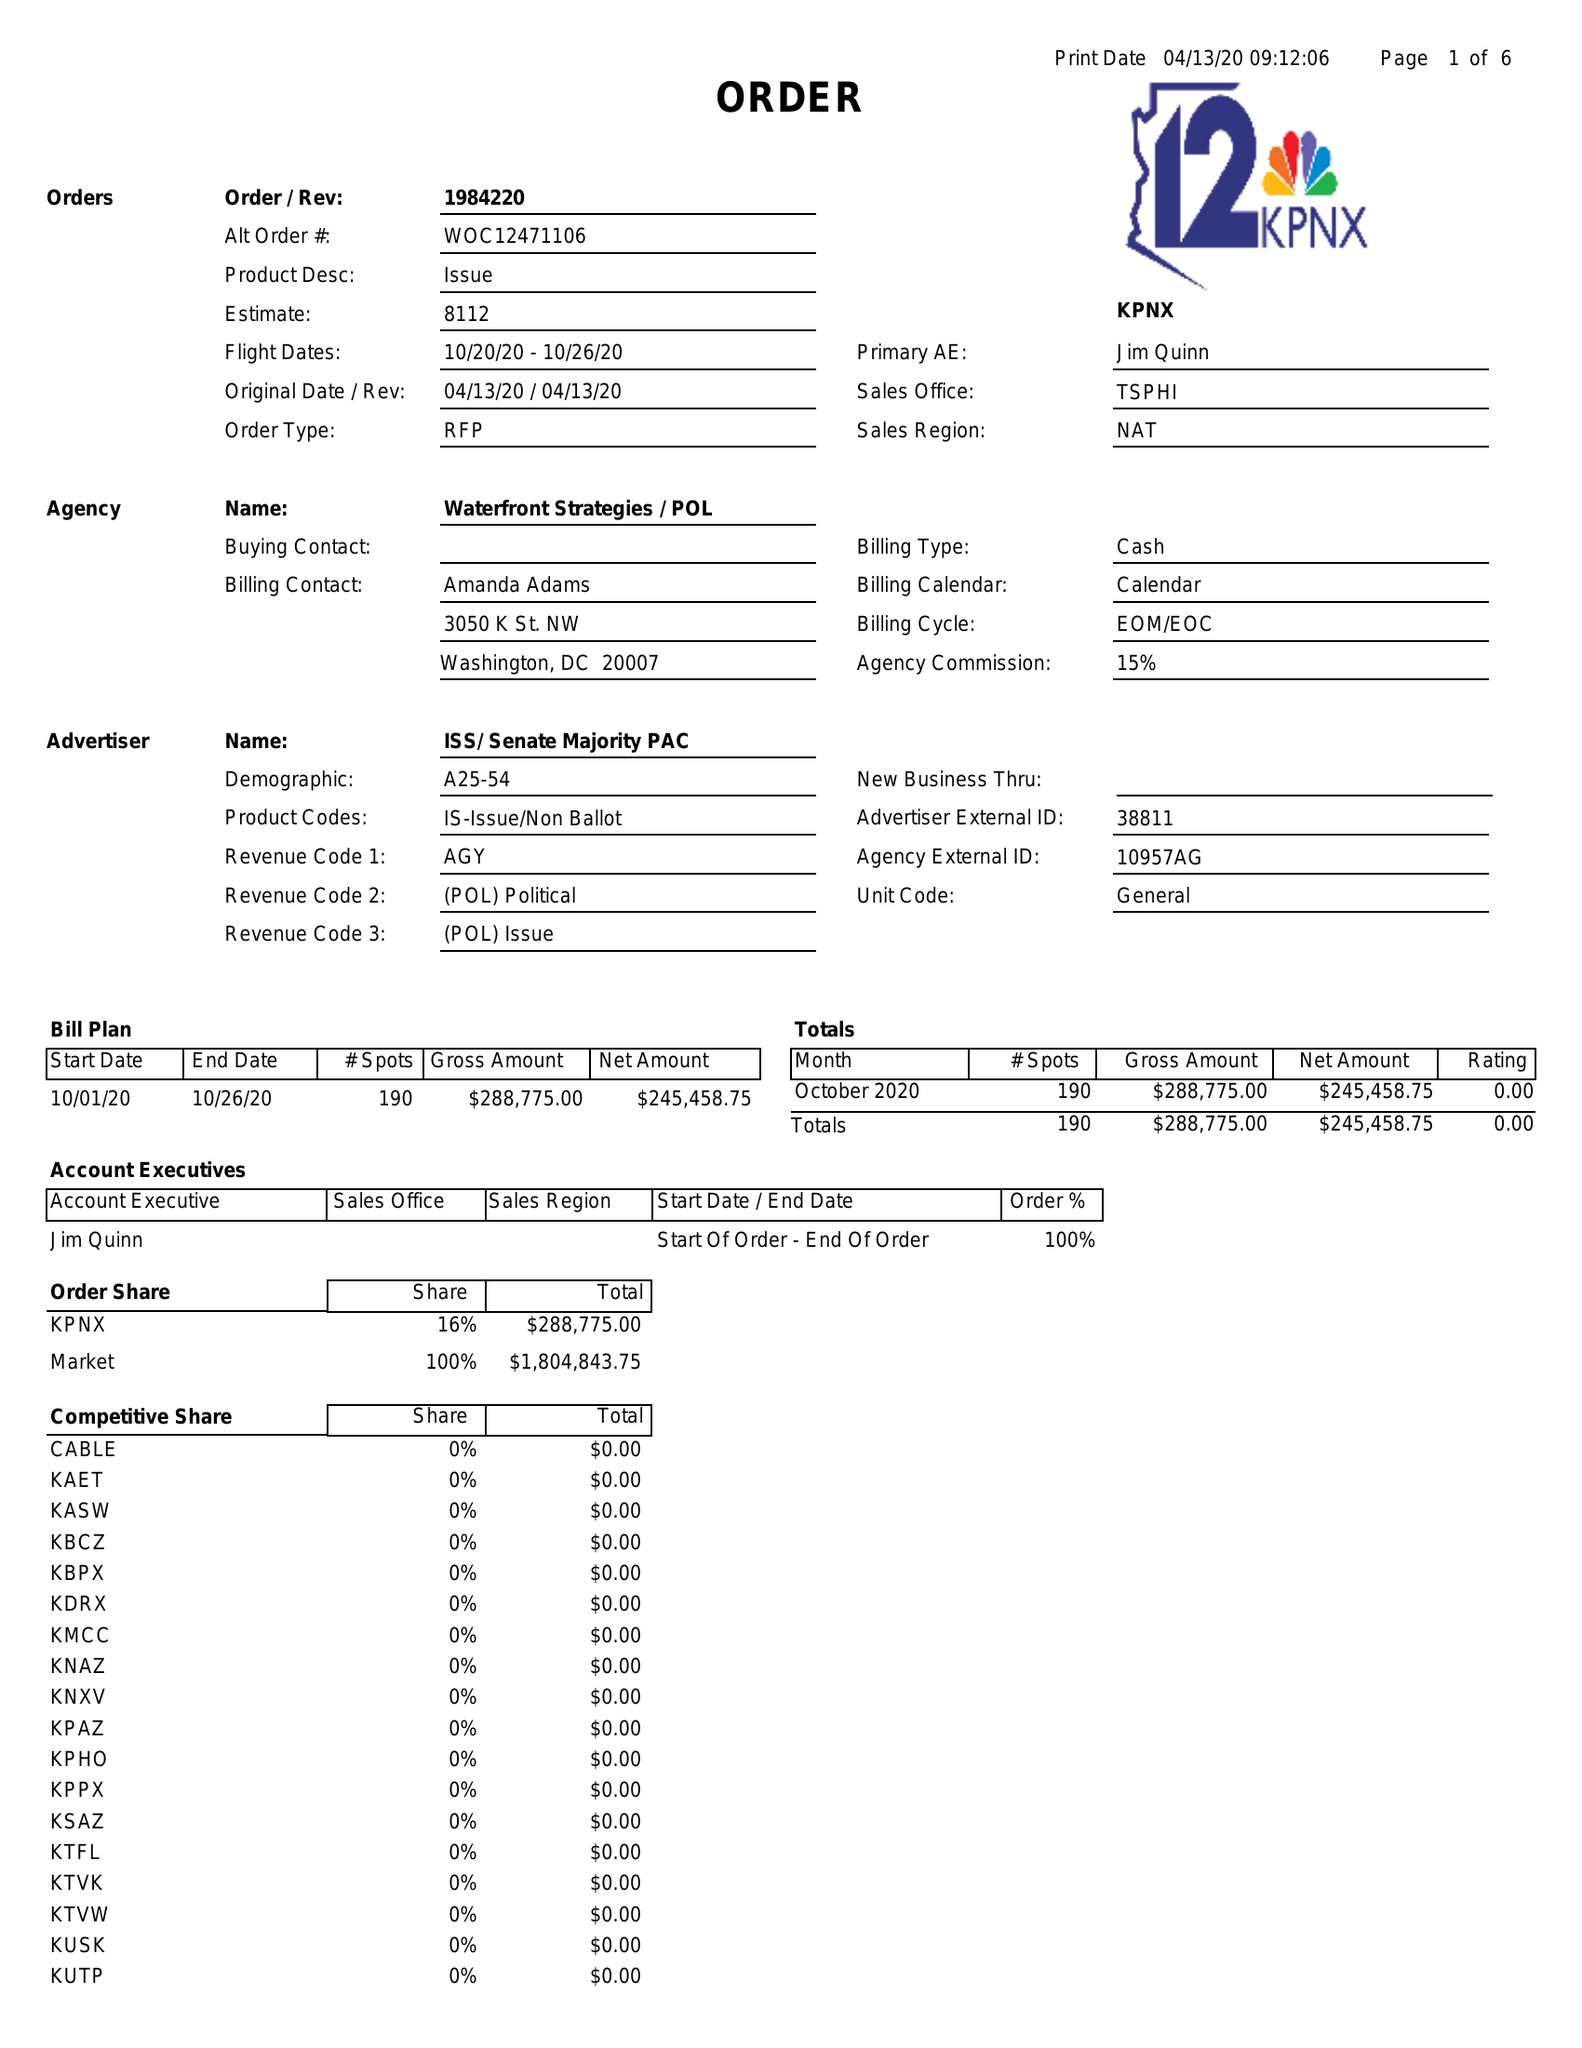What is the value for the advertiser?
Answer the question using a single word or phrase. ISS/SENATEMAJORITYPAC 